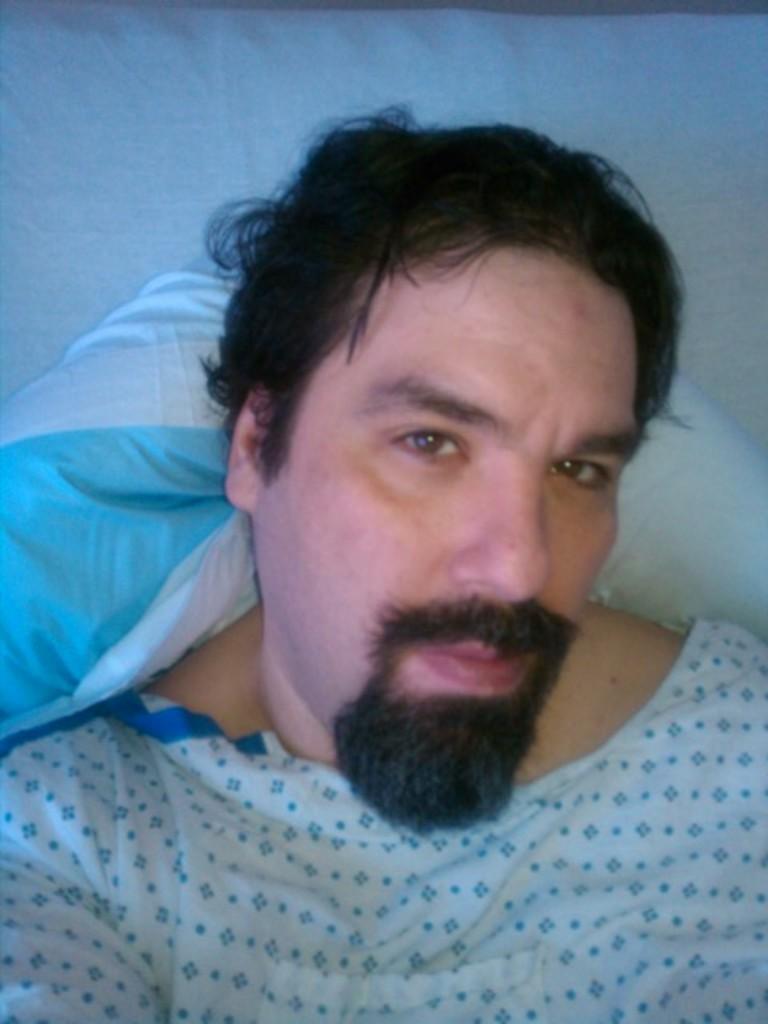Please provide a concise description of this image. In this image I can see a person and the person is wearing white color dress and I can see white color background. 